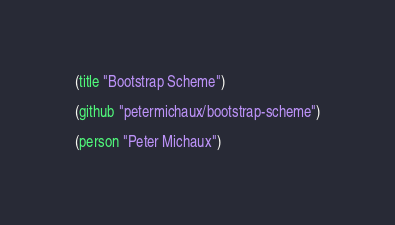<code> <loc_0><loc_0><loc_500><loc_500><_Scheme_>(title "Bootstrap Scheme")

(github "petermichaux/bootstrap-scheme")

(person "Peter Michaux")
</code> 